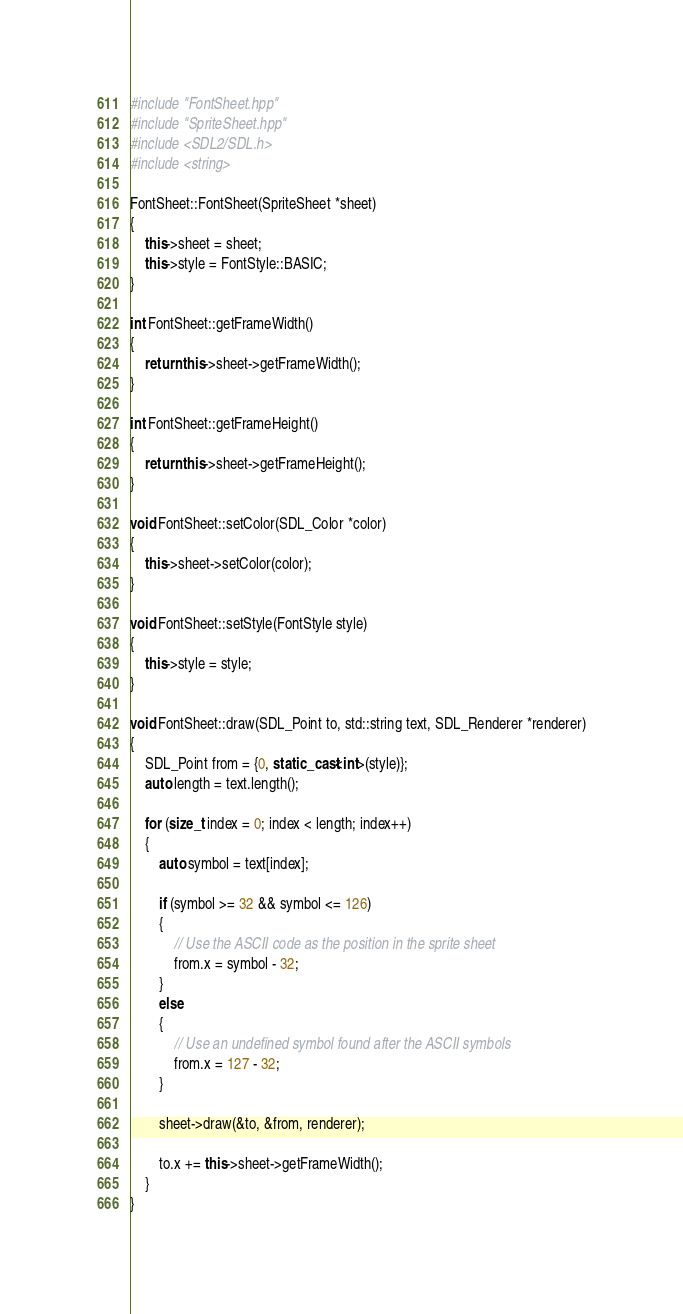<code> <loc_0><loc_0><loc_500><loc_500><_C++_>#include "FontSheet.hpp"
#include "SpriteSheet.hpp"
#include <SDL2/SDL.h>
#include <string>

FontSheet::FontSheet(SpriteSheet *sheet)
{
    this->sheet = sheet;
    this->style = FontStyle::BASIC;
}

int FontSheet::getFrameWidth()
{
    return this->sheet->getFrameWidth();
}

int FontSheet::getFrameHeight()
{
    return this->sheet->getFrameHeight();
}

void FontSheet::setColor(SDL_Color *color)
{
    this->sheet->setColor(color);
}

void FontSheet::setStyle(FontStyle style)
{
    this->style = style;
}

void FontSheet::draw(SDL_Point to, std::string text, SDL_Renderer *renderer)
{
    SDL_Point from = {0, static_cast<int>(style)};
    auto length = text.length();

    for (size_t index = 0; index < length; index++)
    {
        auto symbol = text[index];

        if (symbol >= 32 && symbol <= 126)
        {
            // Use the ASCII code as the position in the sprite sheet
            from.x = symbol - 32;
        }
        else
        {
            // Use an undefined symbol found after the ASCII symbols
            from.x = 127 - 32;
        }

        sheet->draw(&to, &from, renderer);

        to.x += this->sheet->getFrameWidth();
    }
}
</code> 